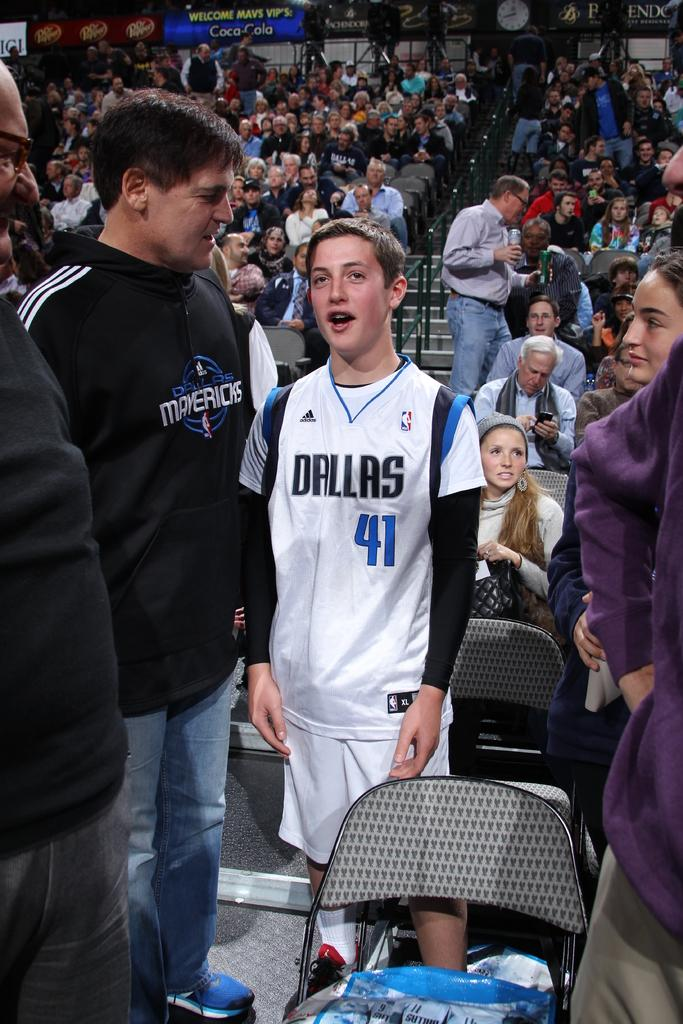<image>
Relay a brief, clear account of the picture shown. A young boy wearing a Dallas 41 white, blue, and black jersey. 